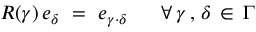<formula> <loc_0><loc_0><loc_500><loc_500>R ( \gamma ) \, e _ { \delta } = e _ { \gamma \cdot \delta } \forall \, \gamma \, , \, \delta \, \in \, \Gamma</formula> 